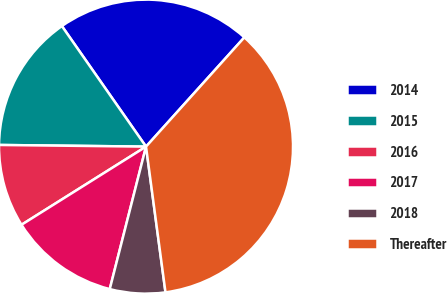Convert chart. <chart><loc_0><loc_0><loc_500><loc_500><pie_chart><fcel>2014<fcel>2015<fcel>2016<fcel>2017<fcel>2018<fcel>Thereafter<nl><fcel>21.36%<fcel>15.12%<fcel>9.1%<fcel>12.11%<fcel>6.08%<fcel>36.22%<nl></chart> 